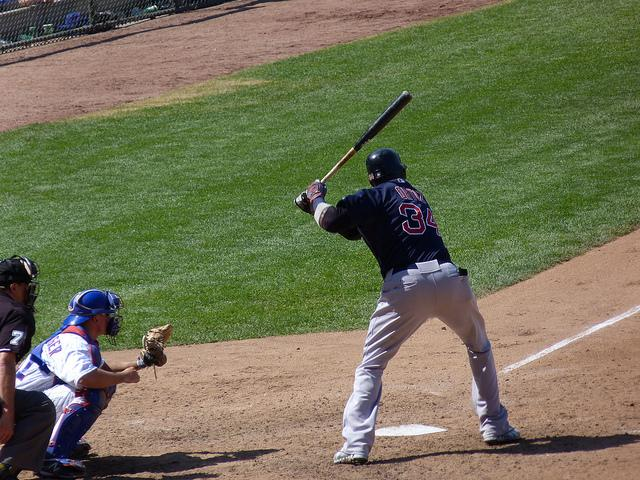What is the nickname of this player? Please explain your reasoning. big papi. A name other players call him. 